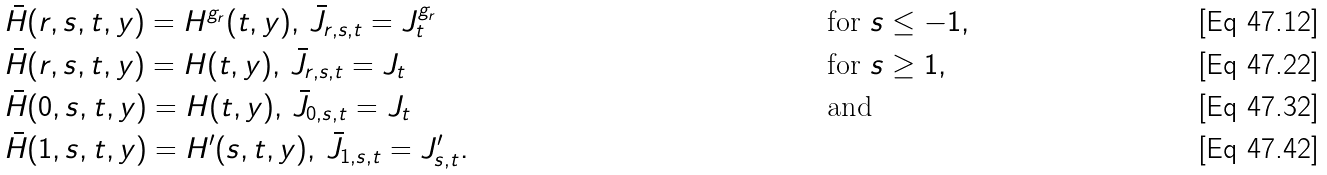<formula> <loc_0><loc_0><loc_500><loc_500>& \bar { H } ( r , s , t , y ) = H ^ { g _ { r } } ( t , y ) , \, \bar { J } _ { r , s , t } = J ^ { g _ { r } } _ { t } & & \text { for } s \leq - 1 , \\ & \bar { H } ( r , s , t , y ) = H ( t , y ) , \, \bar { J } _ { r , s , t } = J _ { t } & & \text { for } s \geq 1 , \\ & \bar { H } ( 0 , s , t , y ) = H ( t , y ) , \, \bar { J } _ { 0 , s , t } = J _ { t } & & \text { and } \\ & \bar { H } ( 1 , s , t , y ) = H ^ { \prime } ( s , t , y ) , \, \bar { J } _ { 1 , s , t } = J _ { s , t } ^ { \prime } . & &</formula> 